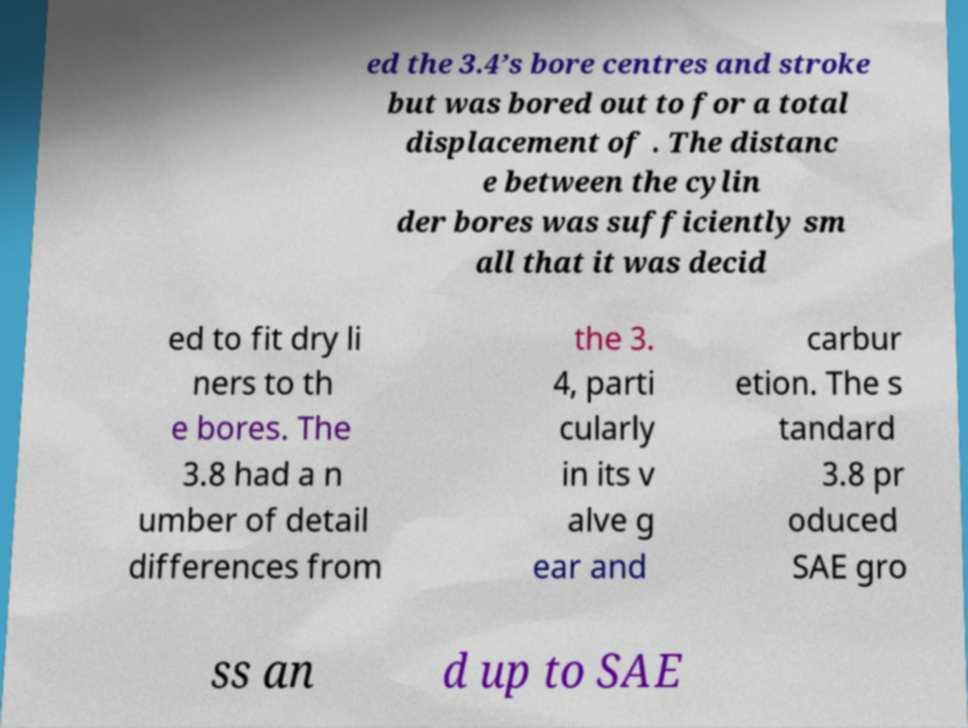What messages or text are displayed in this image? I need them in a readable, typed format. ed the 3.4’s bore centres and stroke but was bored out to for a total displacement of . The distanc e between the cylin der bores was sufficiently sm all that it was decid ed to fit dry li ners to th e bores. The 3.8 had a n umber of detail differences from the 3. 4, parti cularly in its v alve g ear and carbur etion. The s tandard 3.8 pr oduced SAE gro ss an d up to SAE 